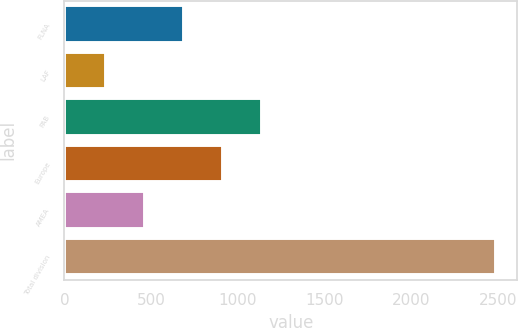Convert chart. <chart><loc_0><loc_0><loc_500><loc_500><bar_chart><fcel>FLNA<fcel>LAF<fcel>PAB<fcel>Europe<fcel>AMEA<fcel>Total division<nl><fcel>687.8<fcel>238<fcel>1137.6<fcel>912.7<fcel>462.9<fcel>2487<nl></chart> 